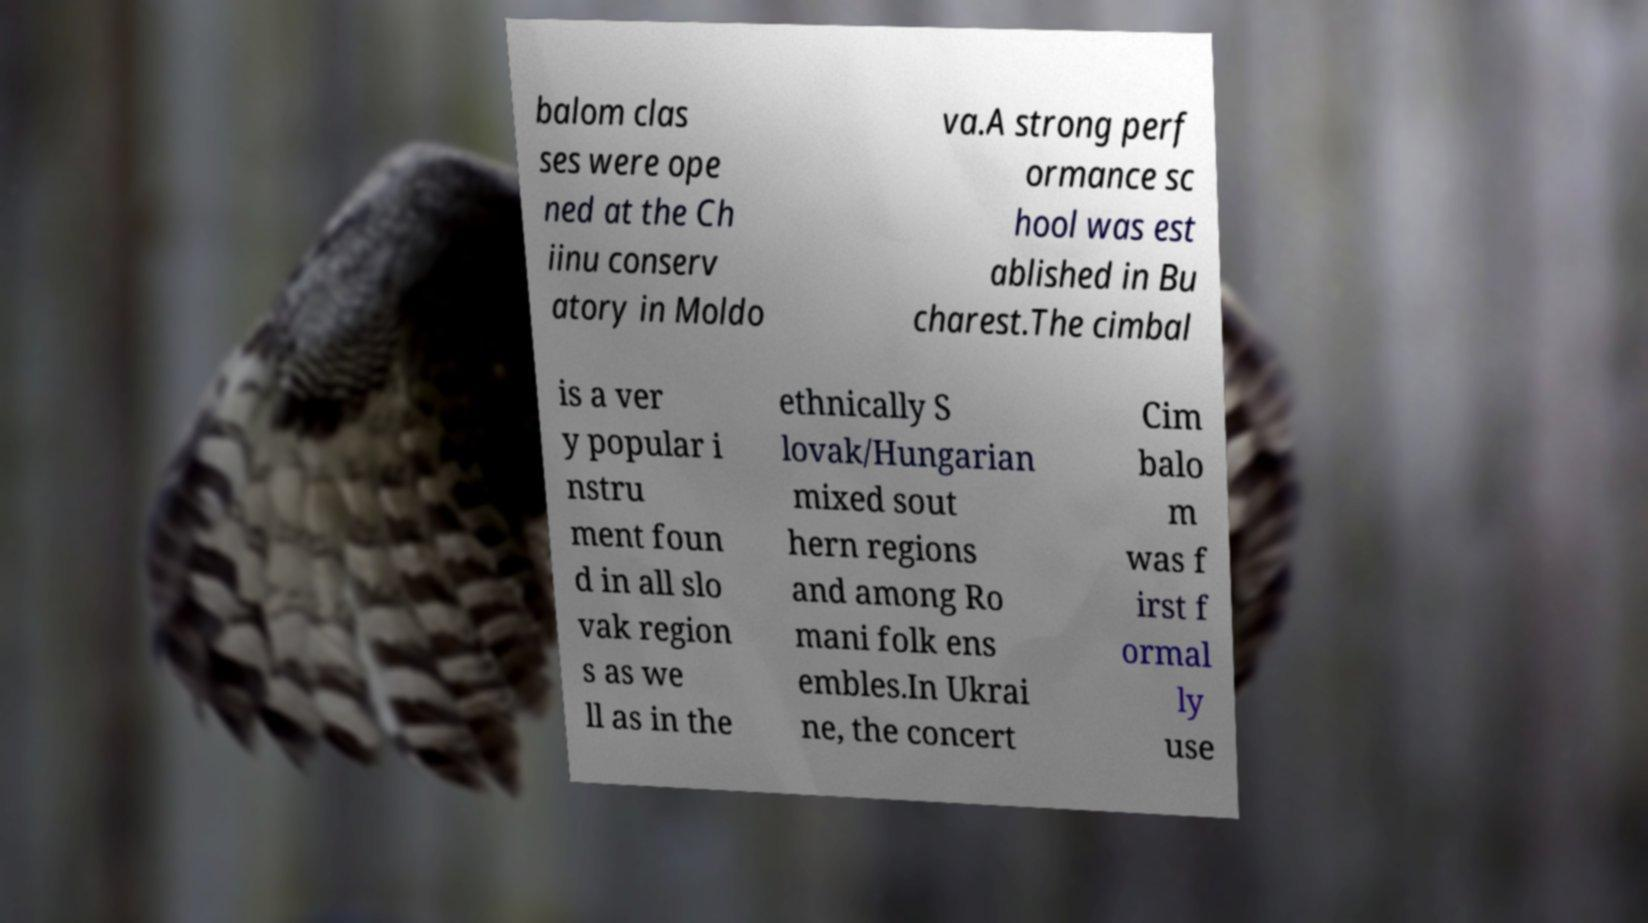What messages or text are displayed in this image? I need them in a readable, typed format. balom clas ses were ope ned at the Ch iinu conserv atory in Moldo va.A strong perf ormance sc hool was est ablished in Bu charest.The cimbal is a ver y popular i nstru ment foun d in all slo vak region s as we ll as in the ethnically S lovak/Hungarian mixed sout hern regions and among Ro mani folk ens embles.In Ukrai ne, the concert Cim balo m was f irst f ormal ly use 